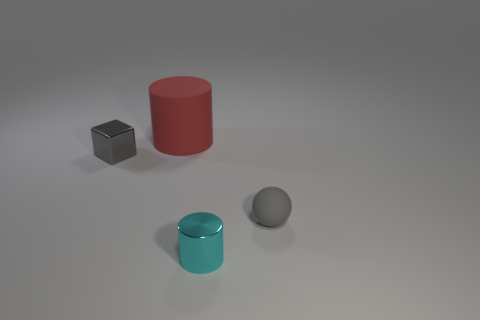Does the small matte object have the same color as the small metallic thing that is behind the metallic cylinder?
Your answer should be compact. Yes. Are there the same number of matte balls that are behind the big red matte object and matte cylinders that are in front of the gray sphere?
Give a very brief answer. Yes. Does the ball have the same material as the small cube left of the cyan metal thing?
Provide a short and direct response. No. There is a cylinder that is the same size as the gray sphere; what is it made of?
Provide a succinct answer. Metal. Is there a gray metal object that is in front of the matte object that is behind the gray object that is to the right of the big object?
Your response must be concise. Yes. The other gray object that is the same size as the gray metallic object is what shape?
Your response must be concise. Sphere. Does the gray object that is behind the small matte thing have the same size as the object that is to the right of the small metallic cylinder?
Your answer should be very brief. Yes. What size is the matte object left of the gray thing that is on the right side of the cylinder in front of the sphere?
Provide a succinct answer. Large. Is the color of the ball the same as the cube?
Offer a very short reply. Yes. Is there anything else that is the same size as the red matte cylinder?
Keep it short and to the point. No. 